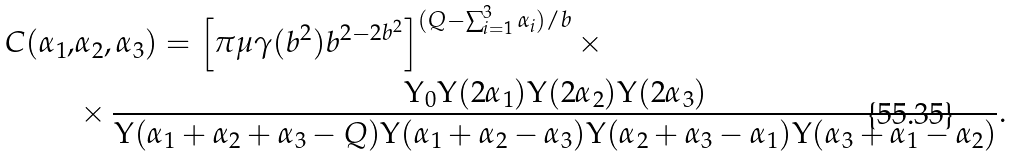<formula> <loc_0><loc_0><loc_500><loc_500>C ( \alpha _ { 1 } , & \alpha _ { 2 } , \alpha _ { 3 } ) = \left [ \pi \mu \gamma ( b ^ { 2 } ) b ^ { 2 - 2 b ^ { 2 } } \right ] ^ { ( Q - \sum _ { i = 1 } ^ { 3 } \alpha _ { i } ) / b } \times \\ & \times \frac { \Upsilon _ { 0 } \Upsilon ( 2 \alpha _ { 1 } ) \Upsilon ( 2 \alpha _ { 2 } ) \Upsilon ( 2 \alpha _ { 3 } ) } { \Upsilon ( \alpha _ { 1 } + \alpha _ { 2 } + \alpha _ { 3 } - Q ) \Upsilon ( \alpha _ { 1 } + \alpha _ { 2 } - \alpha _ { 3 } ) \Upsilon ( \alpha _ { 2 } + \alpha _ { 3 } - \alpha _ { 1 } ) \Upsilon ( \alpha _ { 3 } + \alpha _ { 1 } - \alpha _ { 2 } ) } .</formula> 